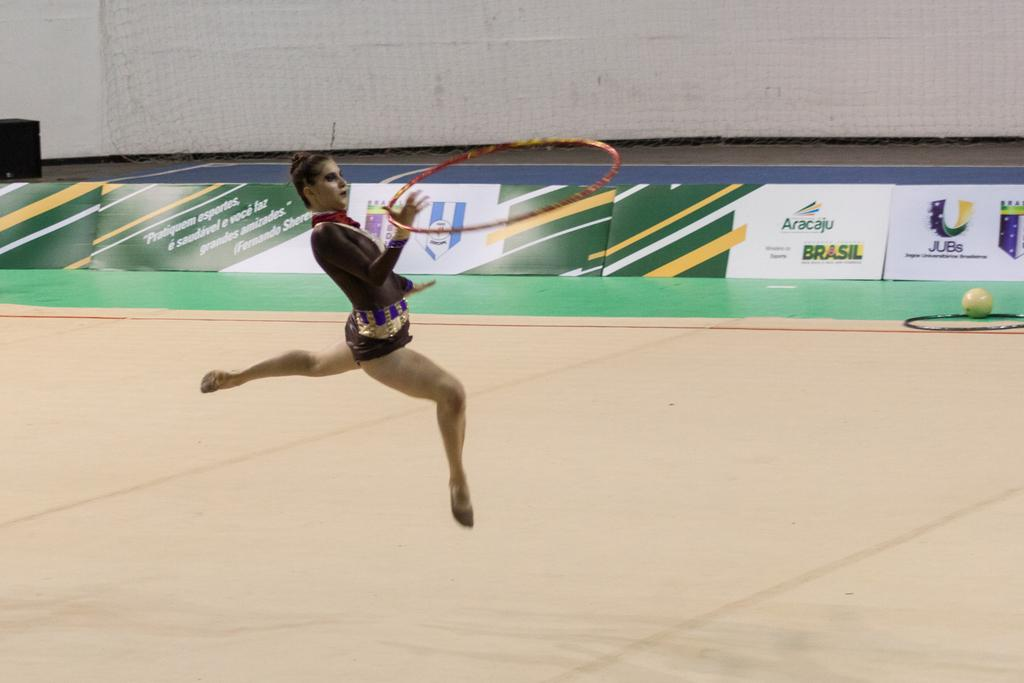<image>
Write a terse but informative summary of the picture. Banners and ads in a sports arena display the words Brasil, Aracaju and JUBs. 